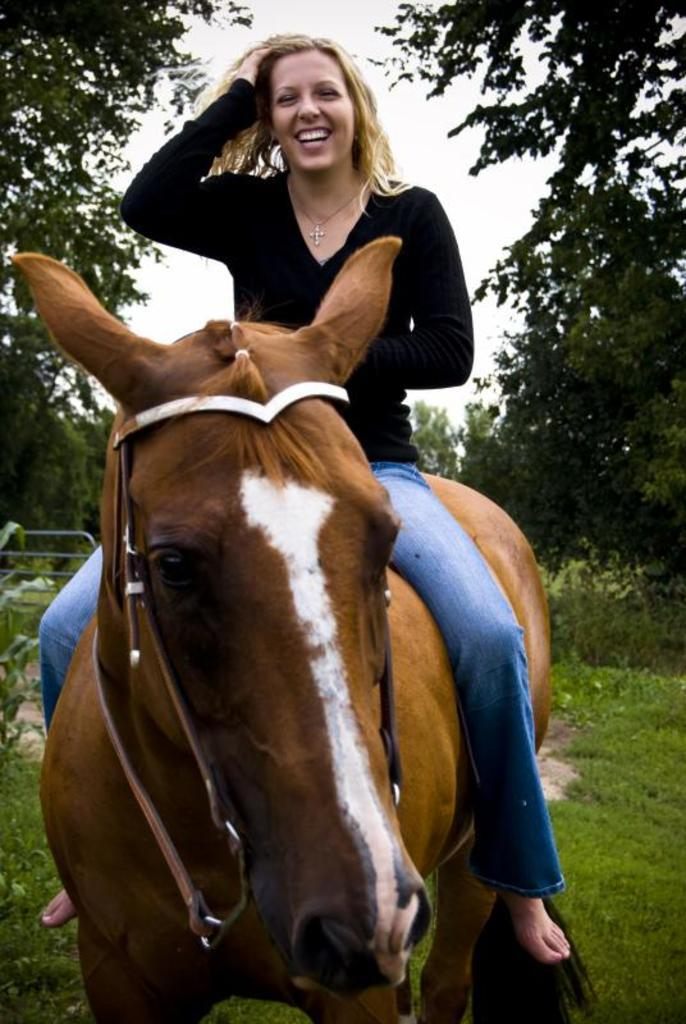Who is the main subject in the image? There is a woman in the image. What is the woman doing in the image? The woman is riding a horse. What is the woman's facial expression in the image? The woman is smiling. What type of natural environment can be seen in the image? There are trees visible in the image. How many women are present in the image? There is only one woman present in the image. What type of coat is the woman wearing in the image? The woman is not wearing a coat in the image. What type of flesh can be seen on the woman in the image? There is no flesh visible on the woman in the image. 